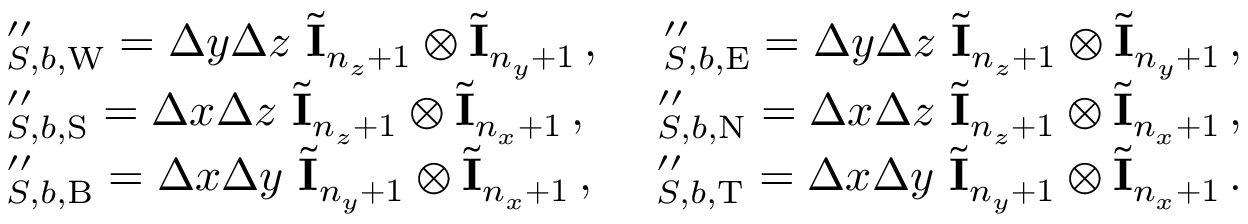<formula> <loc_0><loc_0><loc_500><loc_500>\begin{array} { r l r } & { \mathbf \Lambda _ { S , b , W } ^ { \prime \prime } = \Delta y \Delta z \ \tilde { \mathbf I } _ { n _ { z } + 1 } \otimes \tilde { \mathbf I } _ { n _ { y } + 1 } \, , } & { \mathbf \Lambda _ { S , b , E } ^ { \prime \prime } = \Delta y \Delta z \ \tilde { \mathbf I } _ { n _ { z } + 1 } \otimes \tilde { \mathbf I } _ { n _ { y } + 1 } \, , } \\ & { \mathbf \Lambda _ { S , b , S } ^ { \prime \prime } = \Delta x \Delta z \ \tilde { \mathbf I } _ { n _ { z } + 1 } \otimes \tilde { \mathbf I } _ { n _ { x } + 1 } \, , } & { \mathbf \Lambda _ { S , b , N } ^ { \prime \prime } = \Delta x \Delta z \ \tilde { \mathbf I } _ { n _ { z } + 1 } \otimes \tilde { \mathbf I } _ { n _ { x } + 1 } \, , } \\ & { \mathbf \Lambda _ { S , b , B } ^ { \prime \prime } = \Delta x \Delta y \ \tilde { \mathbf I } _ { n _ { y } + 1 } \otimes \tilde { \mathbf I } _ { n _ { x } + 1 } \, , } & { \mathbf \Lambda _ { S , b , T } ^ { \prime \prime } = \Delta x \Delta y \ \tilde { \mathbf I } _ { n _ { y } + 1 } \otimes \tilde { \mathbf I } _ { n _ { x } + 1 } \, . } \end{array}</formula> 